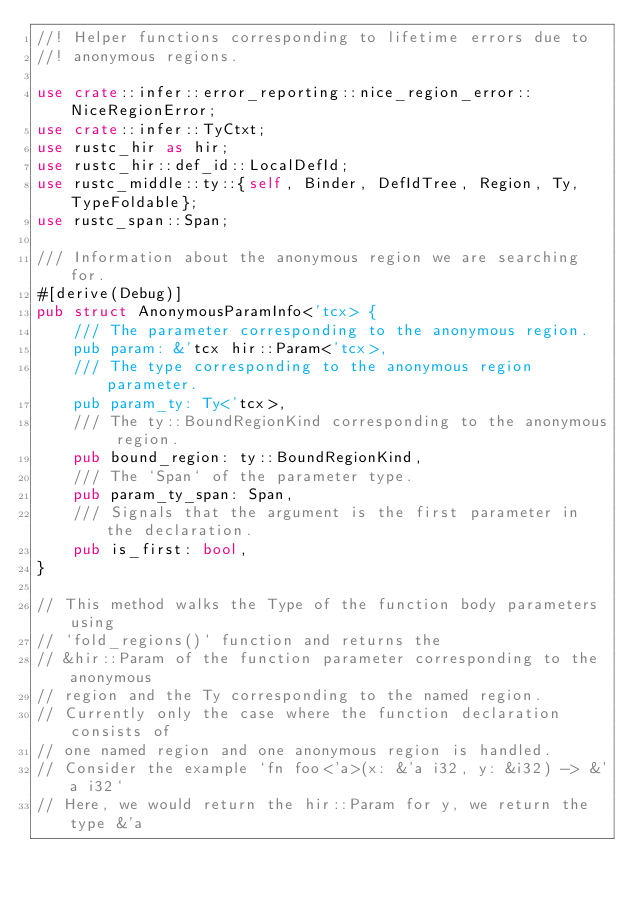Convert code to text. <code><loc_0><loc_0><loc_500><loc_500><_Rust_>//! Helper functions corresponding to lifetime errors due to
//! anonymous regions.

use crate::infer::error_reporting::nice_region_error::NiceRegionError;
use crate::infer::TyCtxt;
use rustc_hir as hir;
use rustc_hir::def_id::LocalDefId;
use rustc_middle::ty::{self, Binder, DefIdTree, Region, Ty, TypeFoldable};
use rustc_span::Span;

/// Information about the anonymous region we are searching for.
#[derive(Debug)]
pub struct AnonymousParamInfo<'tcx> {
    /// The parameter corresponding to the anonymous region.
    pub param: &'tcx hir::Param<'tcx>,
    /// The type corresponding to the anonymous region parameter.
    pub param_ty: Ty<'tcx>,
    /// The ty::BoundRegionKind corresponding to the anonymous region.
    pub bound_region: ty::BoundRegionKind,
    /// The `Span` of the parameter type.
    pub param_ty_span: Span,
    /// Signals that the argument is the first parameter in the declaration.
    pub is_first: bool,
}

// This method walks the Type of the function body parameters using
// `fold_regions()` function and returns the
// &hir::Param of the function parameter corresponding to the anonymous
// region and the Ty corresponding to the named region.
// Currently only the case where the function declaration consists of
// one named region and one anonymous region is handled.
// Consider the example `fn foo<'a>(x: &'a i32, y: &i32) -> &'a i32`
// Here, we would return the hir::Param for y, we return the type &'a</code> 